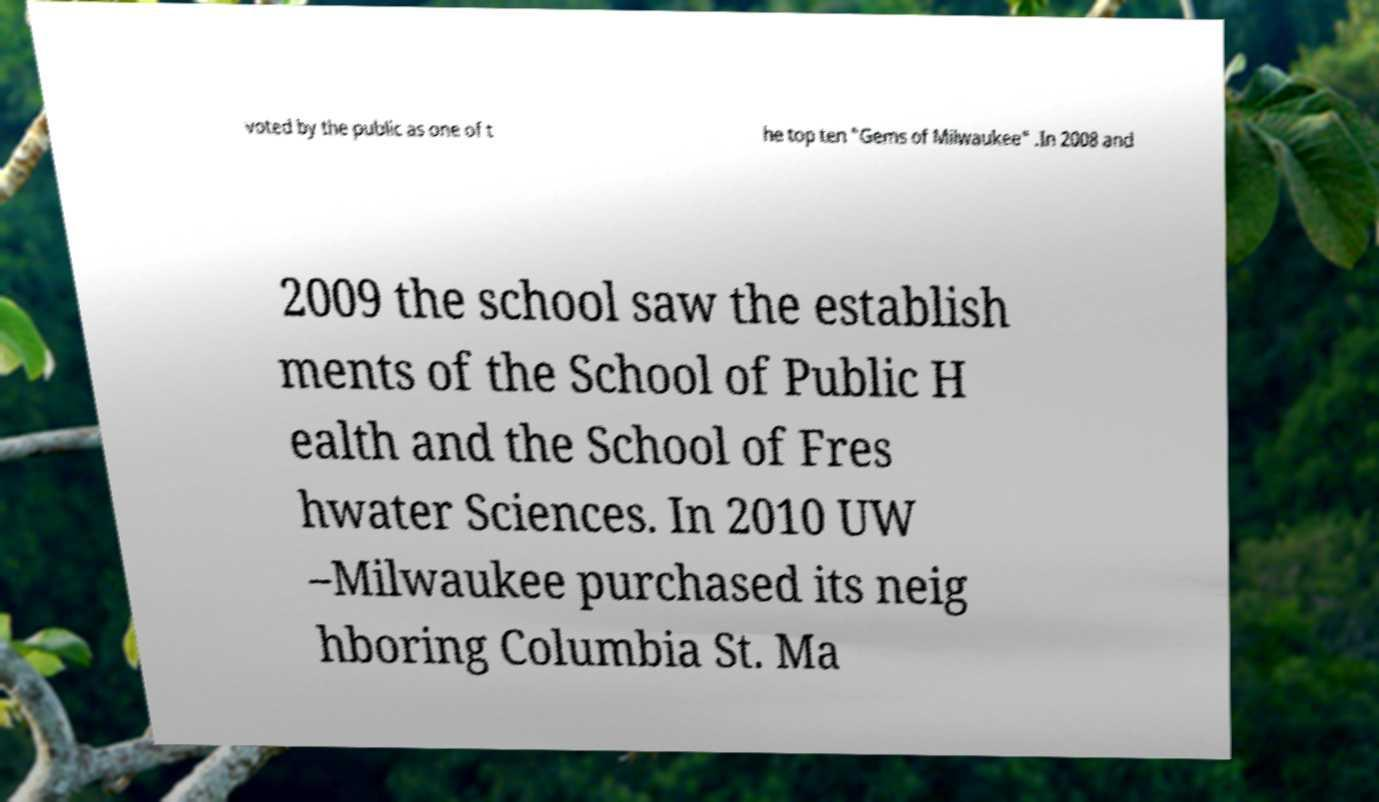Can you accurately transcribe the text from the provided image for me? voted by the public as one of t he top ten "Gems of Milwaukee" .In 2008 and 2009 the school saw the establish ments of the School of Public H ealth and the School of Fres hwater Sciences. In 2010 UW –Milwaukee purchased its neig hboring Columbia St. Ma 